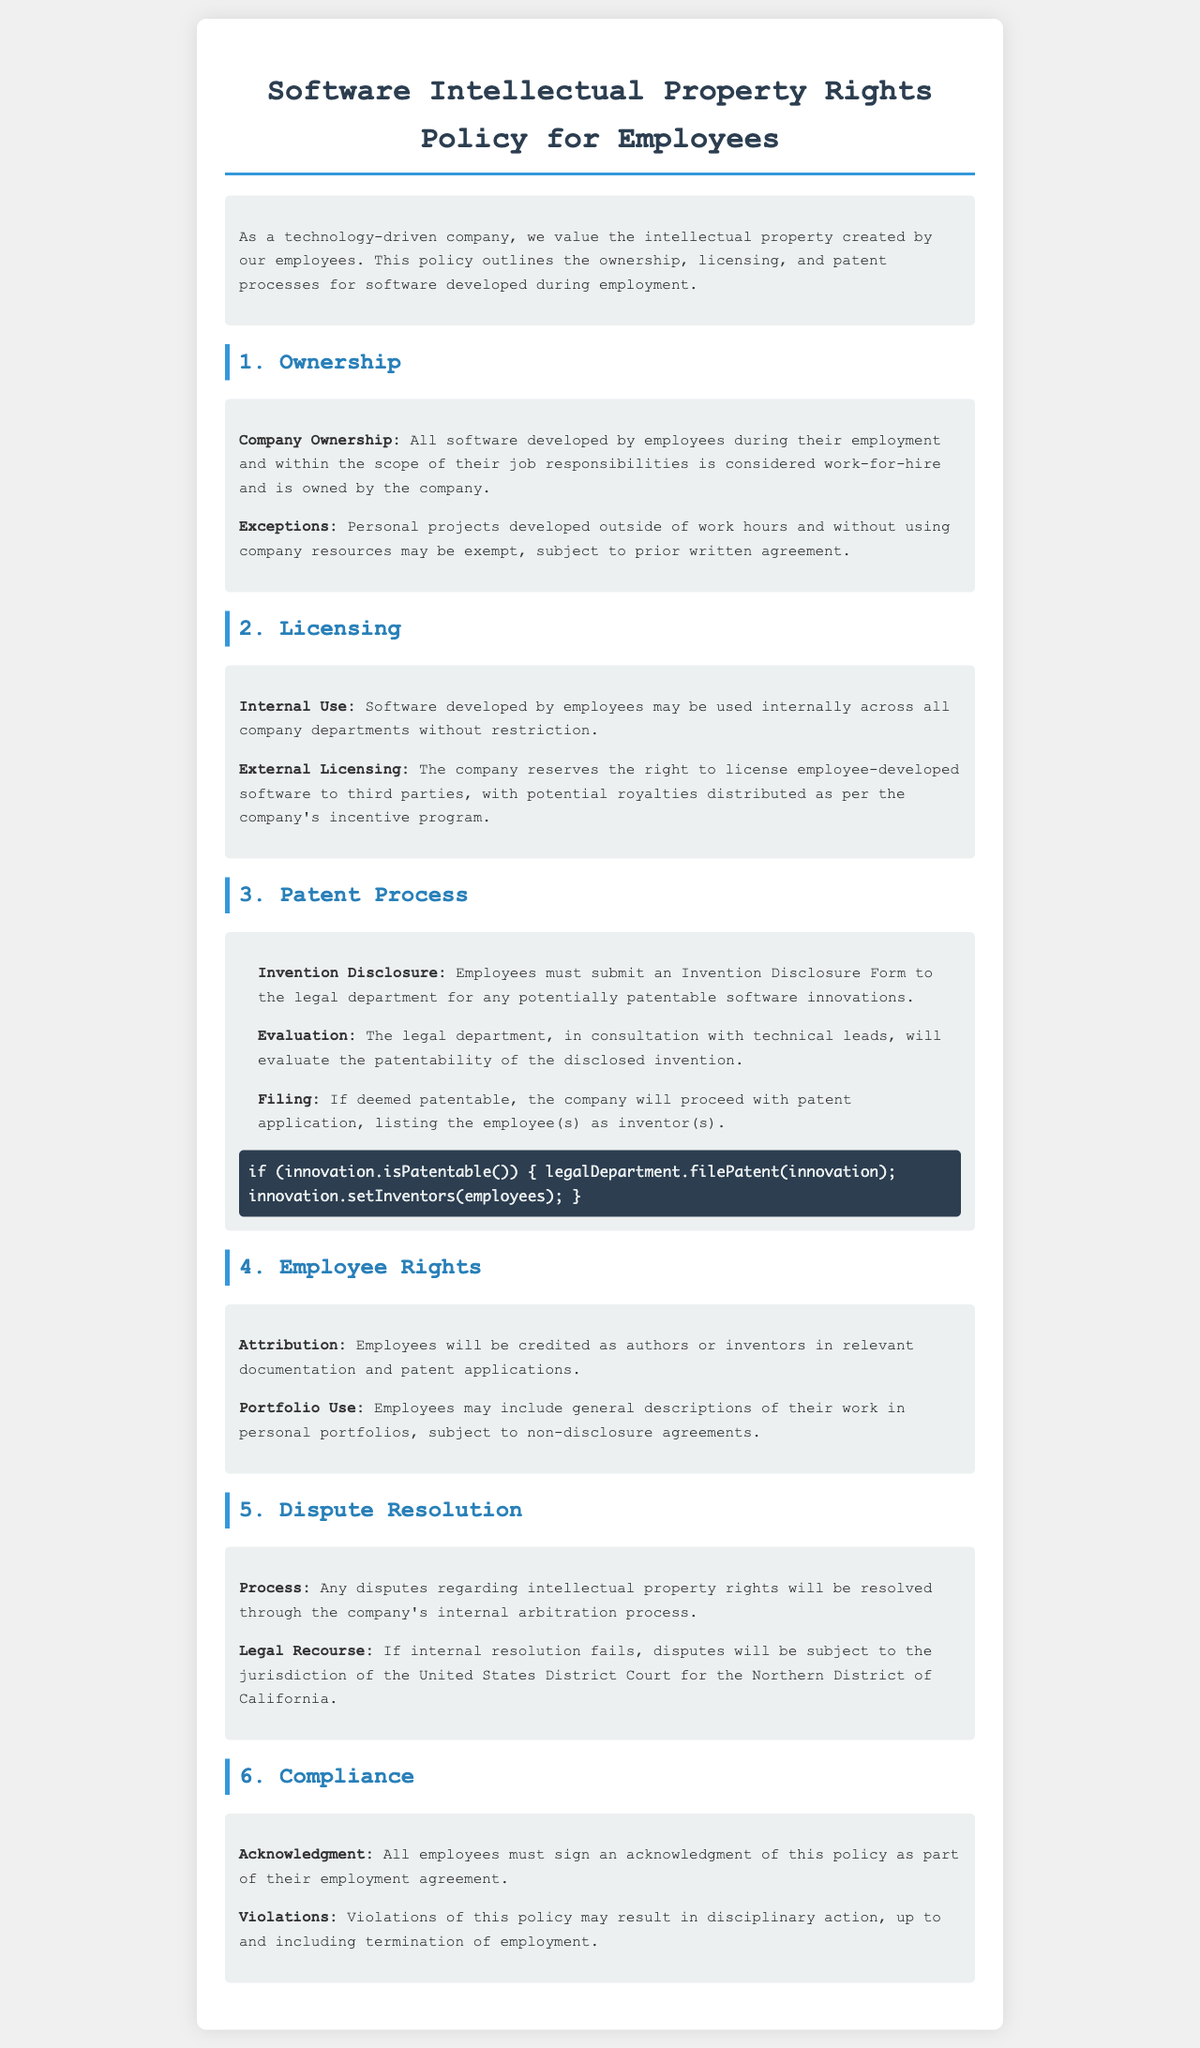What is the document title? The title is mentioned at the top of the document.
Answer: Software Intellectual Property Rights Policy for Employees What is considered work-for-hire? The criteria for work-for-hire is specified under the Ownership section.
Answer: All software developed by employees during their employment and within the scope of their job responsibilities What form must be submitted for potentially patentable innovations? The form required is stated in the Patent Process section.
Answer: Invention Disclosure Form Who evaluates the patentability of disclosed inventions? The responsible party is mentioned in the evaluation process described.
Answer: The legal department Where should disputes regarding intellectual property rights be resolved? The document specifies the resolution process for disputes.
Answer: Internal arbitration process What is the consequence of policy violations? The penalties are noted under the Compliance section.
Answer: Disciplinary action, up to and including termination of employment What must employees do as part of their employment agreement? This requirement is stated in the Compliance section.
Answer: Sign an acknowledgment of this policy Can employees use descriptions of their work in personal portfolios? The policy outlines the allowance regarding portfolios.
Answer: Yes, subject to non-disclosure agreements 